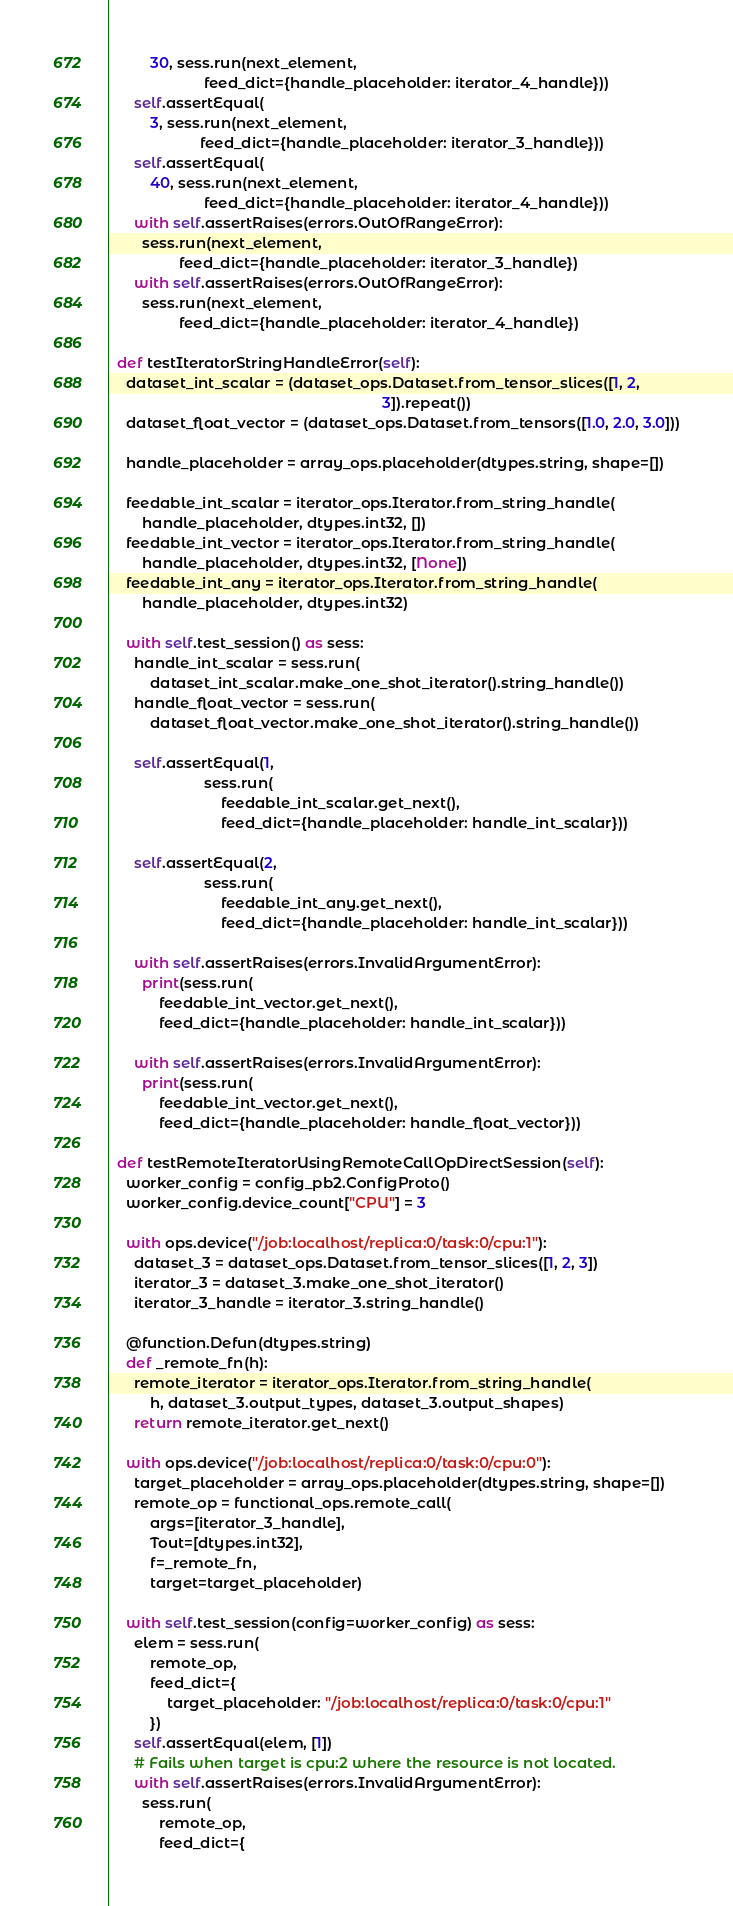Convert code to text. <code><loc_0><loc_0><loc_500><loc_500><_Python_>          30, sess.run(next_element,
                       feed_dict={handle_placeholder: iterator_4_handle}))
      self.assertEqual(
          3, sess.run(next_element,
                      feed_dict={handle_placeholder: iterator_3_handle}))
      self.assertEqual(
          40, sess.run(next_element,
                       feed_dict={handle_placeholder: iterator_4_handle}))
      with self.assertRaises(errors.OutOfRangeError):
        sess.run(next_element,
                 feed_dict={handle_placeholder: iterator_3_handle})
      with self.assertRaises(errors.OutOfRangeError):
        sess.run(next_element,
                 feed_dict={handle_placeholder: iterator_4_handle})

  def testIteratorStringHandleError(self):
    dataset_int_scalar = (dataset_ops.Dataset.from_tensor_slices([1, 2,
                                                                  3]).repeat())
    dataset_float_vector = (dataset_ops.Dataset.from_tensors([1.0, 2.0, 3.0]))

    handle_placeholder = array_ops.placeholder(dtypes.string, shape=[])

    feedable_int_scalar = iterator_ops.Iterator.from_string_handle(
        handle_placeholder, dtypes.int32, [])
    feedable_int_vector = iterator_ops.Iterator.from_string_handle(
        handle_placeholder, dtypes.int32, [None])
    feedable_int_any = iterator_ops.Iterator.from_string_handle(
        handle_placeholder, dtypes.int32)

    with self.test_session() as sess:
      handle_int_scalar = sess.run(
          dataset_int_scalar.make_one_shot_iterator().string_handle())
      handle_float_vector = sess.run(
          dataset_float_vector.make_one_shot_iterator().string_handle())

      self.assertEqual(1,
                       sess.run(
                           feedable_int_scalar.get_next(),
                           feed_dict={handle_placeholder: handle_int_scalar}))

      self.assertEqual(2,
                       sess.run(
                           feedable_int_any.get_next(),
                           feed_dict={handle_placeholder: handle_int_scalar}))

      with self.assertRaises(errors.InvalidArgumentError):
        print(sess.run(
            feedable_int_vector.get_next(),
            feed_dict={handle_placeholder: handle_int_scalar}))

      with self.assertRaises(errors.InvalidArgumentError):
        print(sess.run(
            feedable_int_vector.get_next(),
            feed_dict={handle_placeholder: handle_float_vector}))

  def testRemoteIteratorUsingRemoteCallOpDirectSession(self):
    worker_config = config_pb2.ConfigProto()
    worker_config.device_count["CPU"] = 3

    with ops.device("/job:localhost/replica:0/task:0/cpu:1"):
      dataset_3 = dataset_ops.Dataset.from_tensor_slices([1, 2, 3])
      iterator_3 = dataset_3.make_one_shot_iterator()
      iterator_3_handle = iterator_3.string_handle()

    @function.Defun(dtypes.string)
    def _remote_fn(h):
      remote_iterator = iterator_ops.Iterator.from_string_handle(
          h, dataset_3.output_types, dataset_3.output_shapes)
      return remote_iterator.get_next()

    with ops.device("/job:localhost/replica:0/task:0/cpu:0"):
      target_placeholder = array_ops.placeholder(dtypes.string, shape=[])
      remote_op = functional_ops.remote_call(
          args=[iterator_3_handle],
          Tout=[dtypes.int32],
          f=_remote_fn,
          target=target_placeholder)

    with self.test_session(config=worker_config) as sess:
      elem = sess.run(
          remote_op,
          feed_dict={
              target_placeholder: "/job:localhost/replica:0/task:0/cpu:1"
          })
      self.assertEqual(elem, [1])
      # Fails when target is cpu:2 where the resource is not located.
      with self.assertRaises(errors.InvalidArgumentError):
        sess.run(
            remote_op,
            feed_dict={</code> 